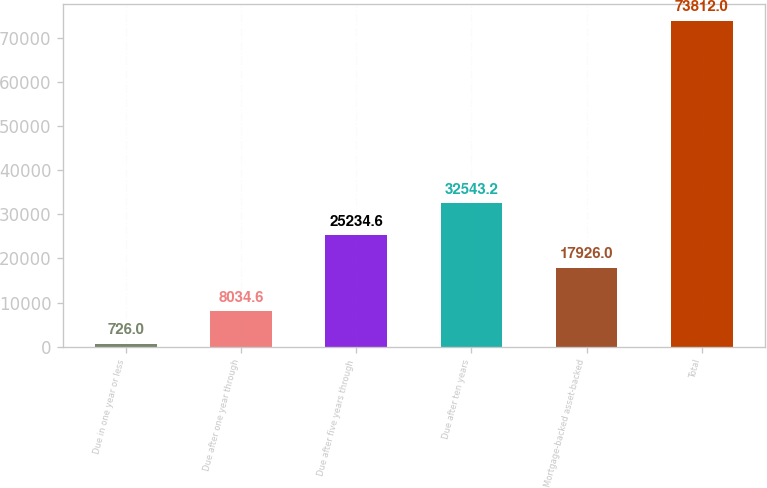<chart> <loc_0><loc_0><loc_500><loc_500><bar_chart><fcel>Due in one year or less<fcel>Due after one year through<fcel>Due after five years through<fcel>Due after ten years<fcel>Mortgage-backed asset-backed<fcel>Total<nl><fcel>726<fcel>8034.6<fcel>25234.6<fcel>32543.2<fcel>17926<fcel>73812<nl></chart> 